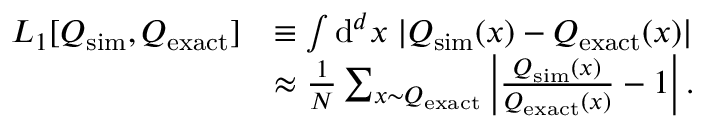<formula> <loc_0><loc_0><loc_500><loc_500>\begin{array} { r l } { L _ { 1 } [ Q _ { s i m } , Q _ { e x a c t } ] } & { \equiv \int d ^ { d } x \, | Q _ { s i m } ( x ) - Q _ { e x a c t } ( x ) | } \\ & { \approx \frac { 1 } { N } \sum _ { x { \sim } Q _ { e x a c t } } \left | \frac { Q _ { s i m } ( x ) } { Q _ { e x a c t } ( x ) } - 1 \right | . } \end{array}</formula> 